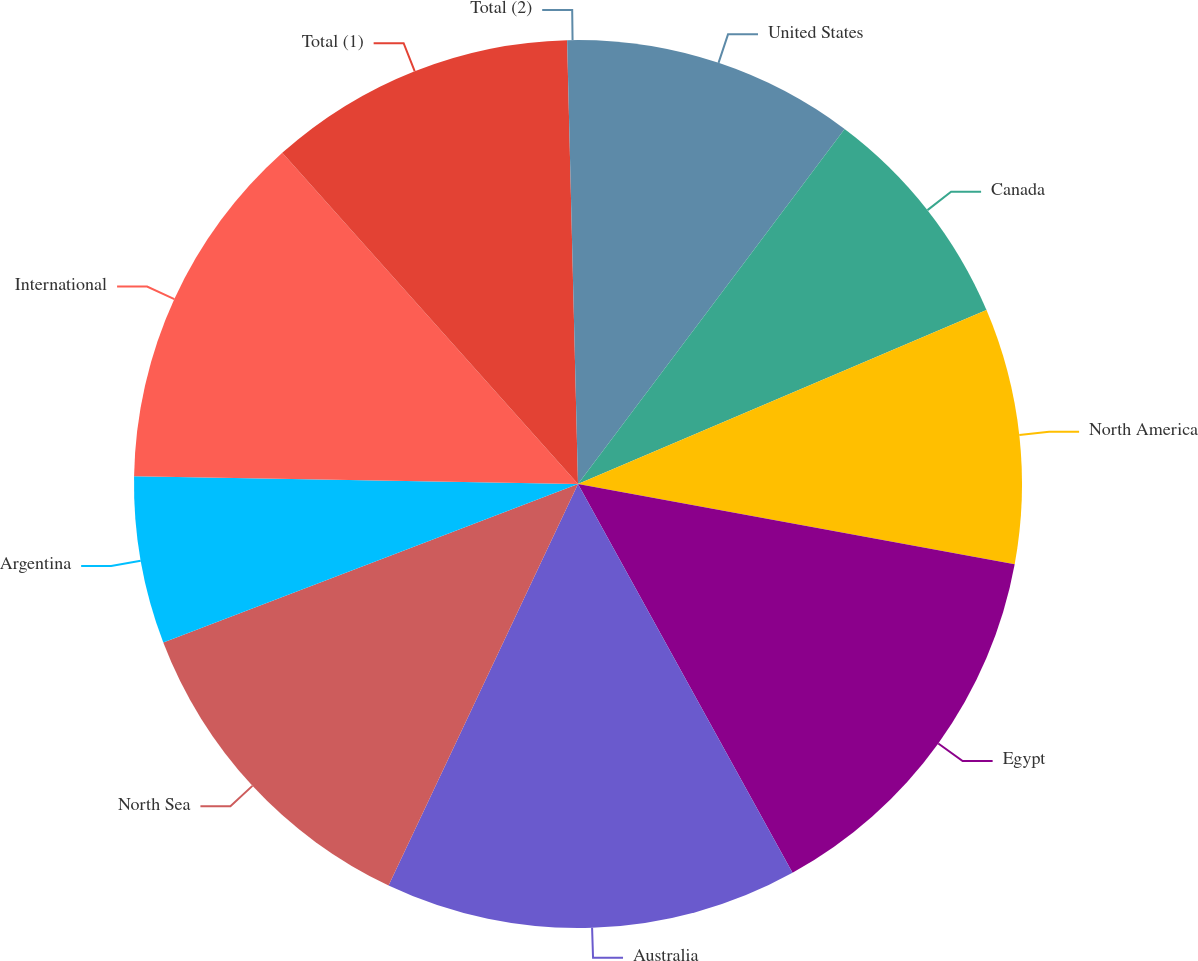Convert chart. <chart><loc_0><loc_0><loc_500><loc_500><pie_chart><fcel>United States<fcel>Canada<fcel>North America<fcel>Egypt<fcel>Australia<fcel>North Sea<fcel>Argentina<fcel>International<fcel>Total (1)<fcel>Total (2)<nl><fcel>10.25%<fcel>8.34%<fcel>9.3%<fcel>14.08%<fcel>15.04%<fcel>12.17%<fcel>6.09%<fcel>13.12%<fcel>11.21%<fcel>0.39%<nl></chart> 